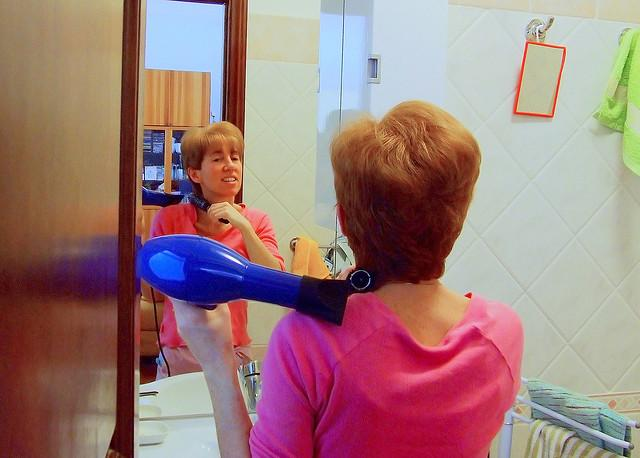What is she doing? drying hair 